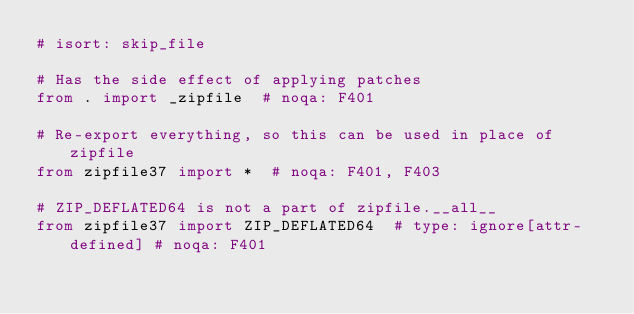<code> <loc_0><loc_0><loc_500><loc_500><_Python_># isort: skip_file

# Has the side effect of applying patches
from . import _zipfile  # noqa: F401

# Re-export everything, so this can be used in place of zipfile
from zipfile37 import *  # noqa: F401, F403

# ZIP_DEFLATED64 is not a part of zipfile.__all__
from zipfile37 import ZIP_DEFLATED64  # type: ignore[attr-defined] # noqa: F401
</code> 